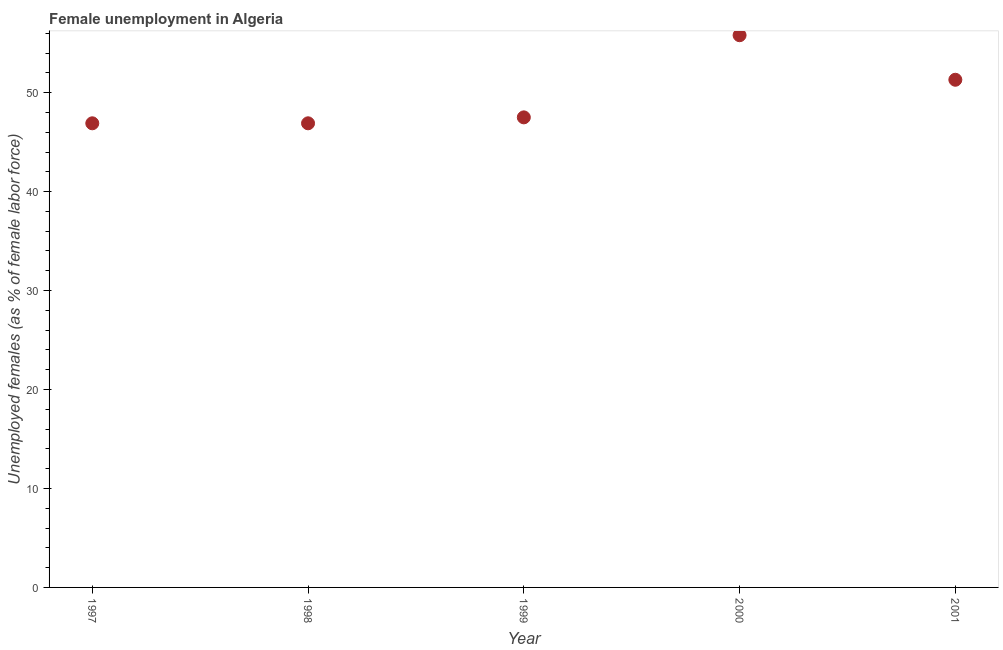What is the unemployed females population in 2000?
Provide a short and direct response. 55.8. Across all years, what is the maximum unemployed females population?
Offer a terse response. 55.8. Across all years, what is the minimum unemployed females population?
Your answer should be compact. 46.9. In which year was the unemployed females population minimum?
Offer a very short reply. 1997. What is the sum of the unemployed females population?
Offer a very short reply. 248.4. What is the difference between the unemployed females population in 1998 and 2001?
Provide a succinct answer. -4.4. What is the average unemployed females population per year?
Give a very brief answer. 49.68. What is the median unemployed females population?
Give a very brief answer. 47.5. In how many years, is the unemployed females population greater than 30 %?
Your response must be concise. 5. What is the difference between the highest and the second highest unemployed females population?
Your response must be concise. 4.5. What is the difference between the highest and the lowest unemployed females population?
Offer a terse response. 8.9. Does the unemployed females population monotonically increase over the years?
Provide a succinct answer. No. What is the difference between two consecutive major ticks on the Y-axis?
Your answer should be compact. 10. Does the graph contain any zero values?
Your response must be concise. No. What is the title of the graph?
Offer a terse response. Female unemployment in Algeria. What is the label or title of the Y-axis?
Make the answer very short. Unemployed females (as % of female labor force). What is the Unemployed females (as % of female labor force) in 1997?
Your answer should be very brief. 46.9. What is the Unemployed females (as % of female labor force) in 1998?
Offer a very short reply. 46.9. What is the Unemployed females (as % of female labor force) in 1999?
Keep it short and to the point. 47.5. What is the Unemployed females (as % of female labor force) in 2000?
Ensure brevity in your answer.  55.8. What is the Unemployed females (as % of female labor force) in 2001?
Provide a short and direct response. 51.3. What is the difference between the Unemployed females (as % of female labor force) in 1997 and 1998?
Make the answer very short. 0. What is the difference between the Unemployed females (as % of female labor force) in 1997 and 2001?
Offer a terse response. -4.4. What is the difference between the Unemployed females (as % of female labor force) in 2000 and 2001?
Make the answer very short. 4.5. What is the ratio of the Unemployed females (as % of female labor force) in 1997 to that in 1998?
Make the answer very short. 1. What is the ratio of the Unemployed females (as % of female labor force) in 1997 to that in 2000?
Provide a short and direct response. 0.84. What is the ratio of the Unemployed females (as % of female labor force) in 1997 to that in 2001?
Give a very brief answer. 0.91. What is the ratio of the Unemployed females (as % of female labor force) in 1998 to that in 1999?
Provide a short and direct response. 0.99. What is the ratio of the Unemployed females (as % of female labor force) in 1998 to that in 2000?
Provide a succinct answer. 0.84. What is the ratio of the Unemployed females (as % of female labor force) in 1998 to that in 2001?
Ensure brevity in your answer.  0.91. What is the ratio of the Unemployed females (as % of female labor force) in 1999 to that in 2000?
Make the answer very short. 0.85. What is the ratio of the Unemployed females (as % of female labor force) in 1999 to that in 2001?
Offer a very short reply. 0.93. What is the ratio of the Unemployed females (as % of female labor force) in 2000 to that in 2001?
Offer a very short reply. 1.09. 